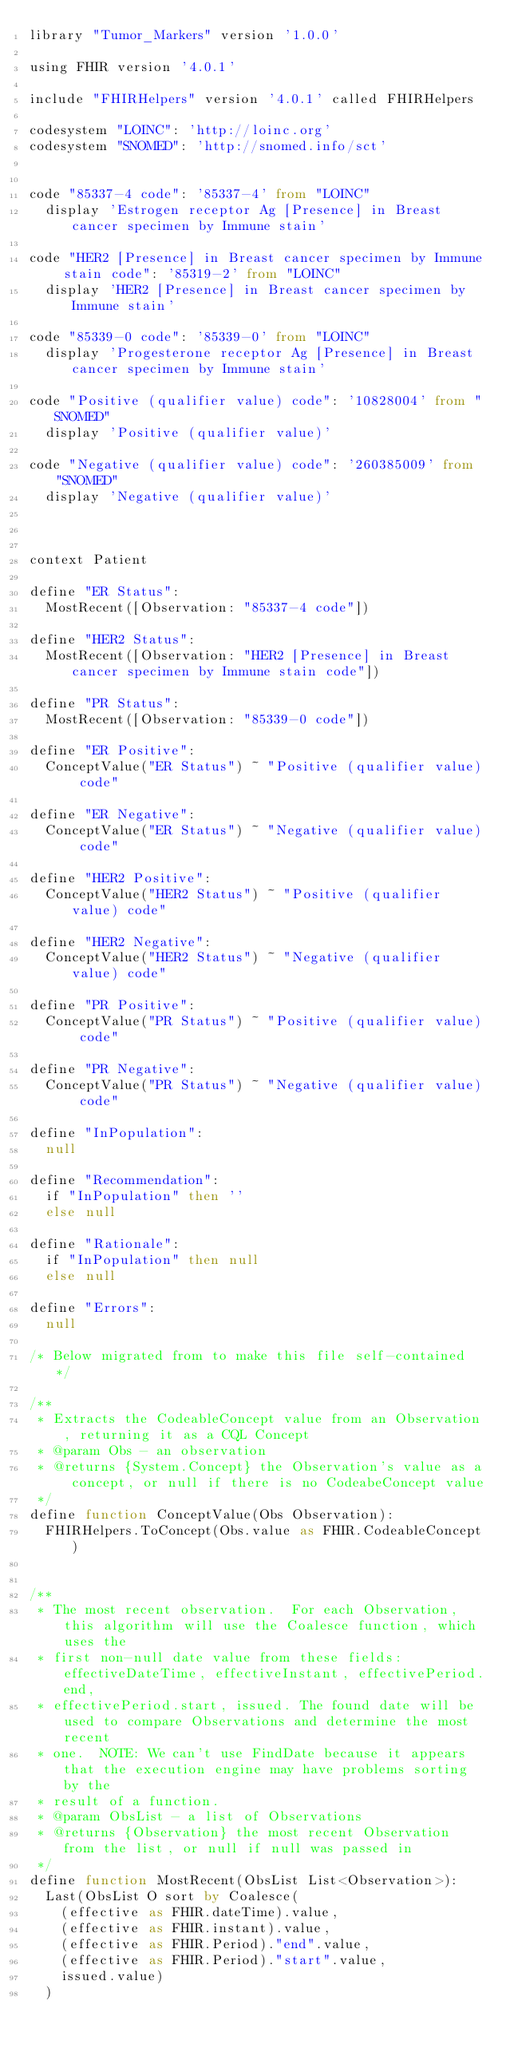Convert code to text. <code><loc_0><loc_0><loc_500><loc_500><_SQL_>library "Tumor_Markers" version '1.0.0'

using FHIR version '4.0.1'

include "FHIRHelpers" version '4.0.1' called FHIRHelpers 

codesystem "LOINC": 'http://loinc.org' 
codesystem "SNOMED": 'http://snomed.info/sct' 


code "85337-4 code": '85337-4' from "LOINC"
  display 'Estrogen receptor Ag [Presence] in Breast cancer specimen by Immune stain'

code "HER2 [Presence] in Breast cancer specimen by Immune stain code": '85319-2' from "LOINC"
  display 'HER2 [Presence] in Breast cancer specimen by Immune stain'

code "85339-0 code": '85339-0' from "LOINC"
  display 'Progesterone receptor Ag [Presence] in Breast cancer specimen by Immune stain'

code "Positive (qualifier value) code": '10828004' from "SNOMED"
  display 'Positive (qualifier value)'

code "Negative (qualifier value) code": '260385009' from "SNOMED"
  display 'Negative (qualifier value)'



context Patient

define "ER Status":
  MostRecent([Observation: "85337-4 code"])

define "HER2 Status":
  MostRecent([Observation: "HER2 [Presence] in Breast cancer specimen by Immune stain code"])

define "PR Status":
  MostRecent([Observation: "85339-0 code"])

define "ER Positive":
  ConceptValue("ER Status") ~ "Positive (qualifier value) code"

define "ER Negative":
  ConceptValue("ER Status") ~ "Negative (qualifier value) code"

define "HER2 Positive":
  ConceptValue("HER2 Status") ~ "Positive (qualifier value) code"

define "HER2 Negative":
  ConceptValue("HER2 Status") ~ "Negative (qualifier value) code"

define "PR Positive":
  ConceptValue("PR Status") ~ "Positive (qualifier value) code"

define "PR Negative":
  ConceptValue("PR Status") ~ "Negative (qualifier value) code"

define "InPopulation":
  null

define "Recommendation": 
  if "InPopulation" then ''
  else null

define "Rationale":
  if "InPopulation" then null
  else null

define "Errors":
  null

/* Below migrated from to make this file self-contained */

/**
 * Extracts the CodeableConcept value from an Observation, returning it as a CQL Concept
 * @param Obs - an observation
 * @returns {System.Concept} the Observation's value as a concept, or null if there is no CodeabeConcept value
 */
define function ConceptValue(Obs Observation):
  FHIRHelpers.ToConcept(Obs.value as FHIR.CodeableConcept)


/**
 * The most recent observation.  For each Observation, this algorithm will use the Coalesce function, which uses the
 * first non-null date value from these fields: effectiveDateTime, effectiveInstant, effectivePeriod.end,
 * effectivePeriod.start, issued. The found date will be used to compare Observations and determine the most recent
 * one.  NOTE: We can't use FindDate because it appears that the execution engine may have problems sorting by the
 * result of a function.
 * @param ObsList - a list of Observations
 * @returns {Observation} the most recent Observation from the list, or null if null was passed in
 */
define function MostRecent(ObsList List<Observation>):
  Last(ObsList O sort by Coalesce(
    (effective as FHIR.dateTime).value,
    (effective as FHIR.instant).value,
    (effective as FHIR.Period)."end".value,
    (effective as FHIR.Period)."start".value,
    issued.value)
  )
</code> 